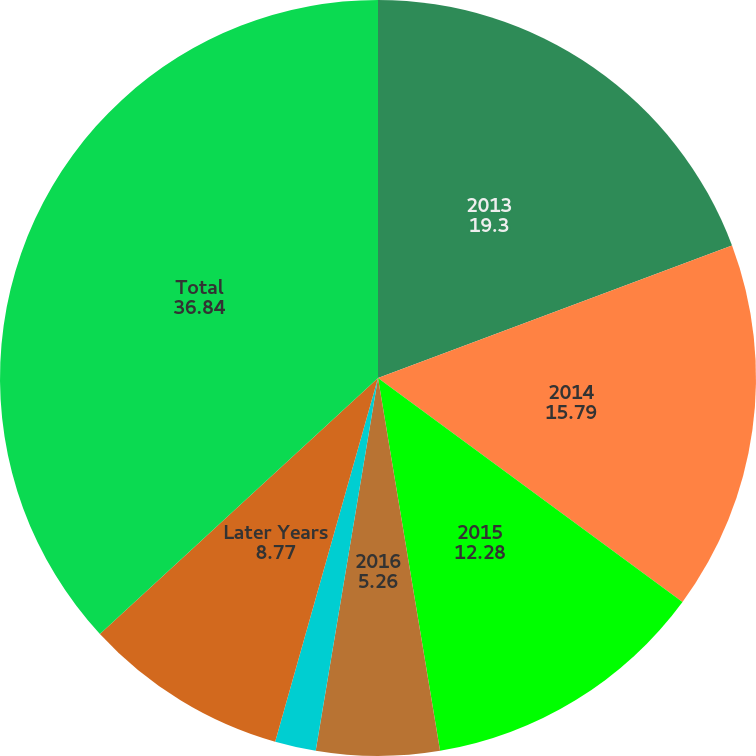Convert chart to OTSL. <chart><loc_0><loc_0><loc_500><loc_500><pie_chart><fcel>2013<fcel>2014<fcel>2015<fcel>2016<fcel>2017<fcel>Later Years<fcel>Total<nl><fcel>19.3%<fcel>15.79%<fcel>12.28%<fcel>5.26%<fcel>1.75%<fcel>8.77%<fcel>36.84%<nl></chart> 